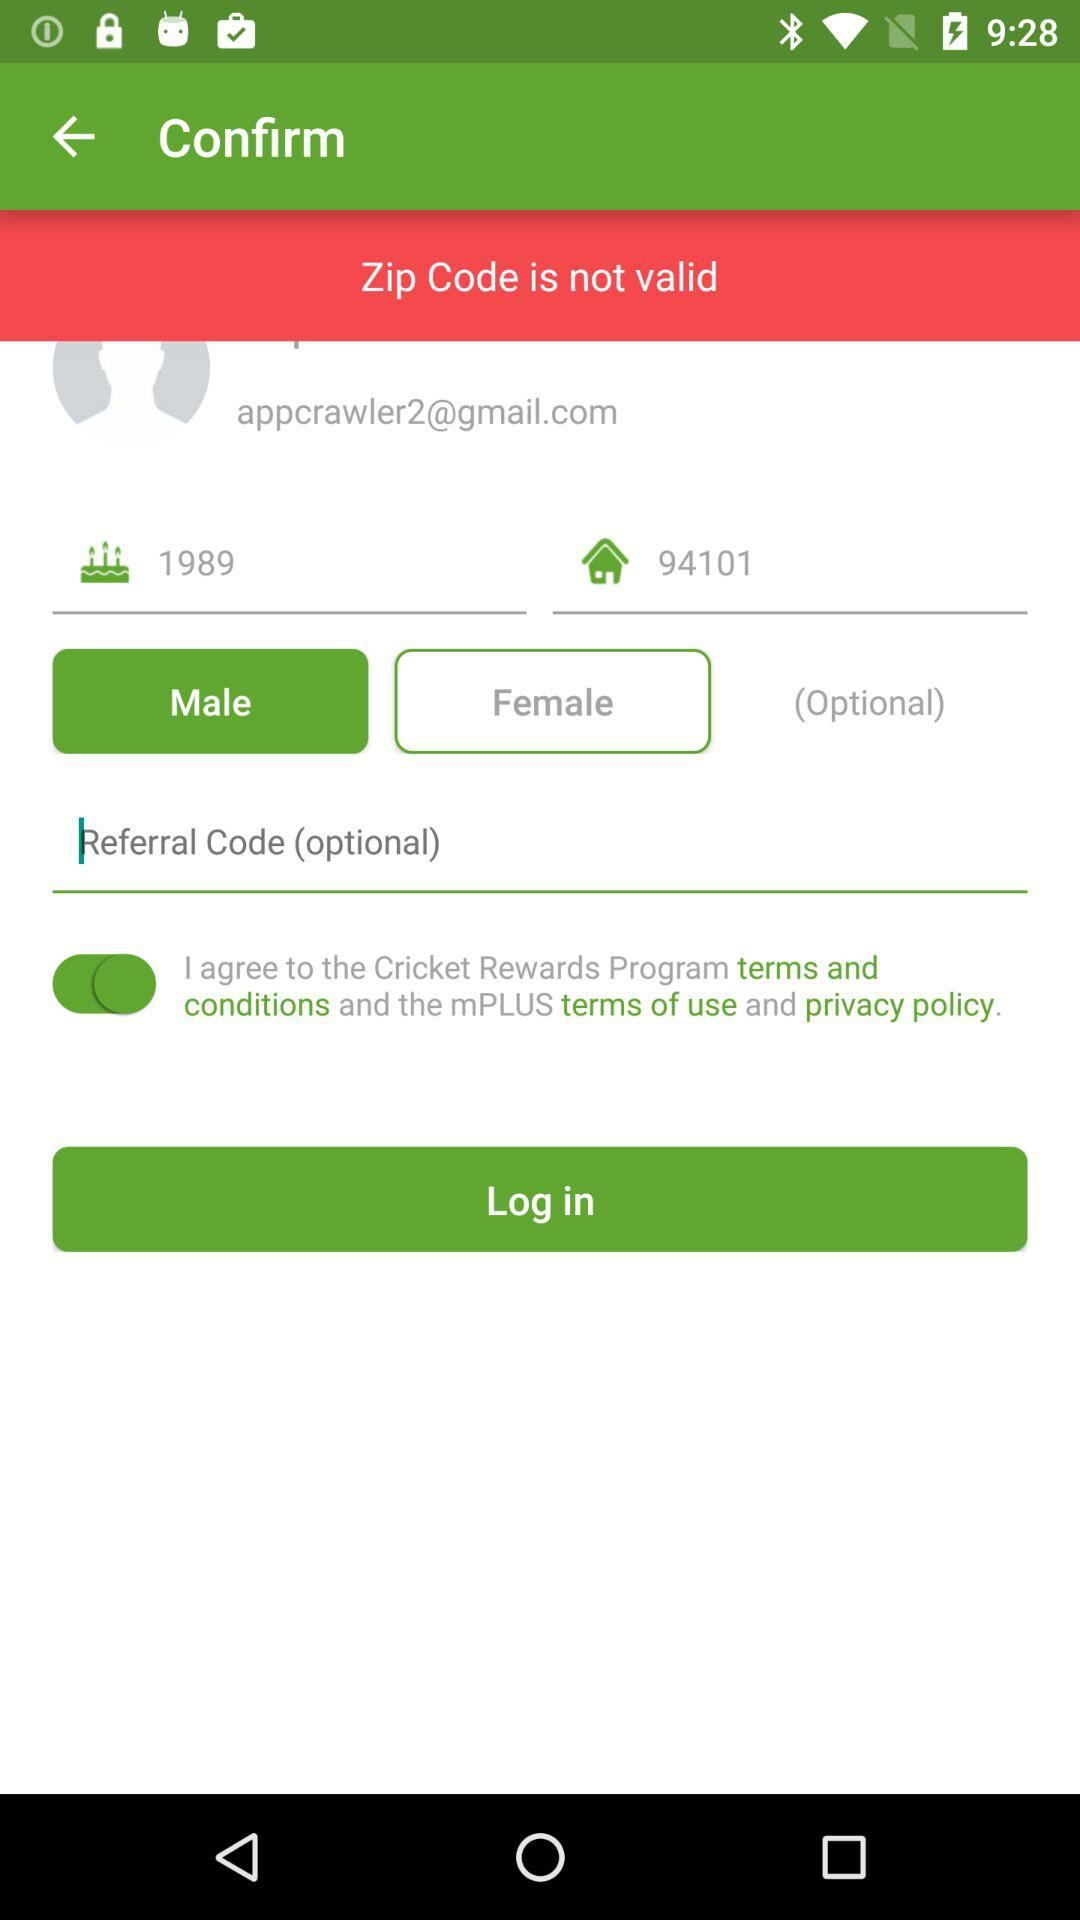What is the given year? The given year is 1989. 